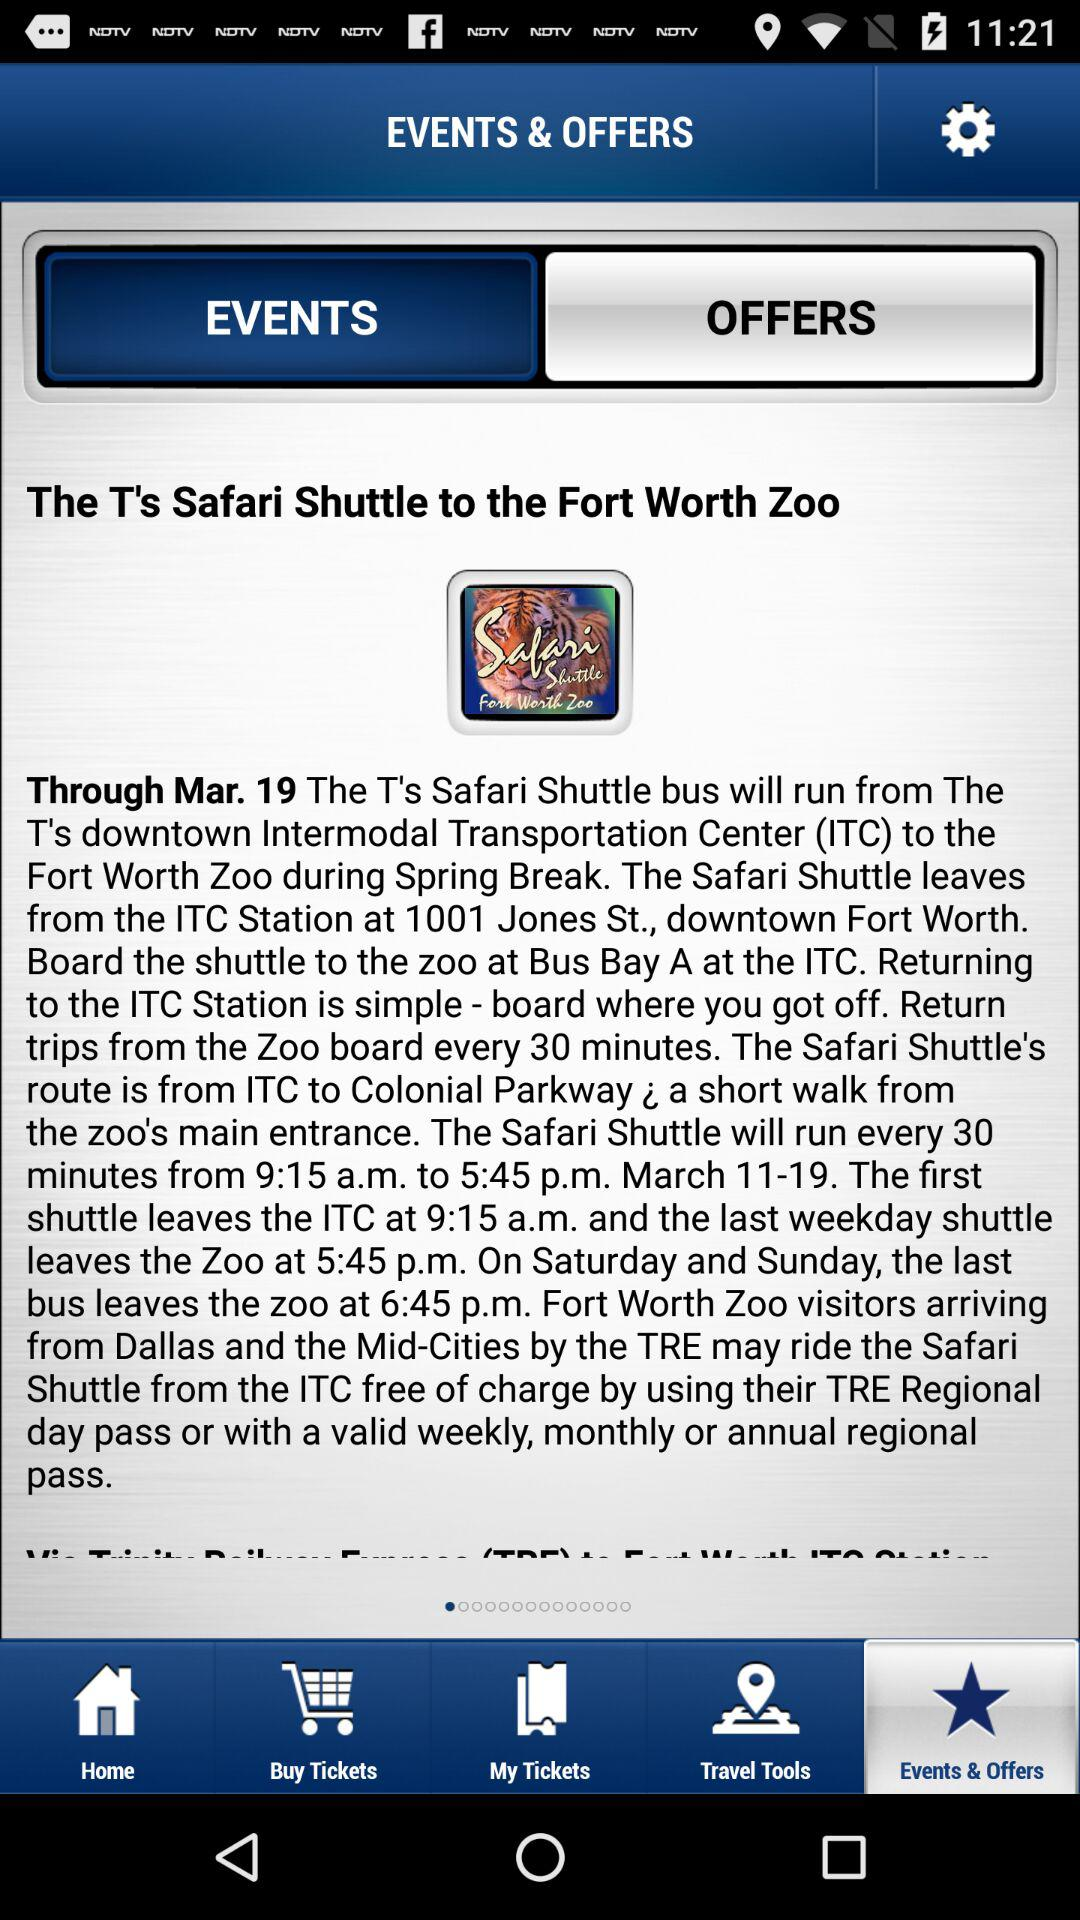What date is shown? The shown date is March 19. 